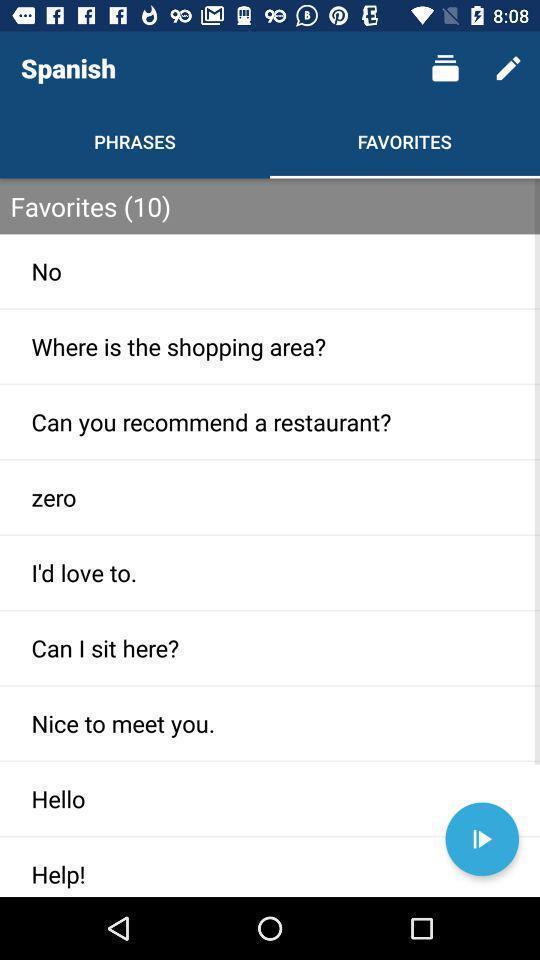Give me a narrative description of this picture. Page showing the list of favorites. 